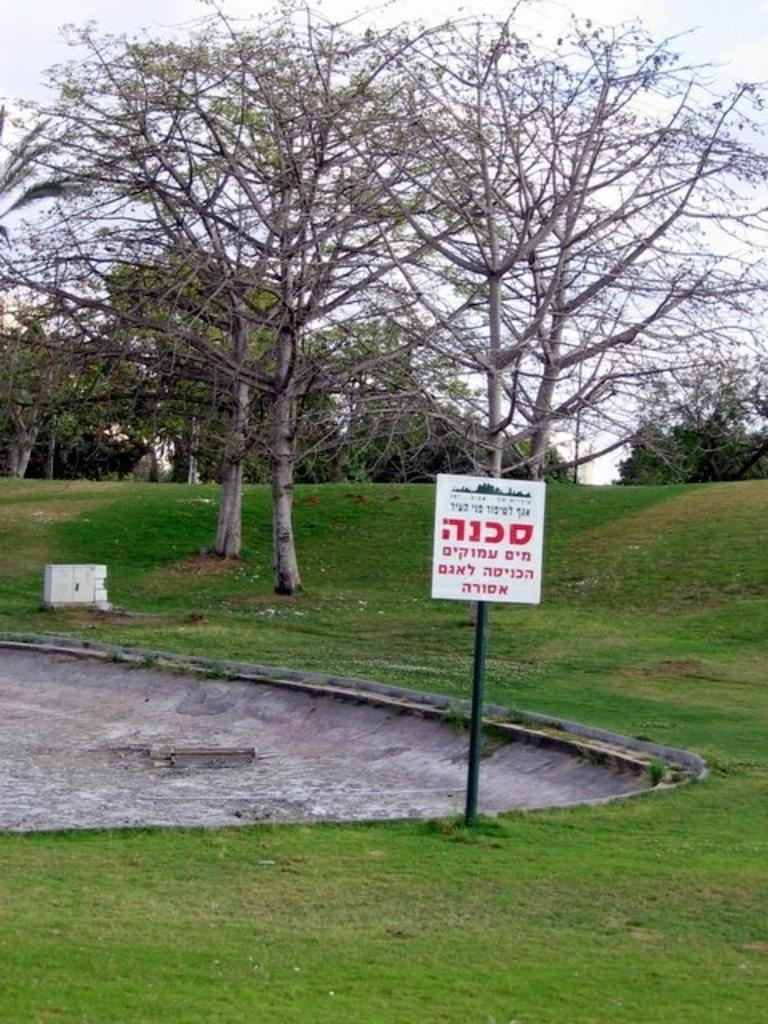What is attached to the pole in the image? There is a board attached to the pole in the image. What type of structure is present near the pole? There is a small wall in the image. What type of vegetation can be seen in the image? There are trees in the image. What is visible in the sky in the image? There are clouds visible in the image. What type of education does the son receive in the image? There is no son or education present in the image. What is the limit of the clouds visible in the image? The clouds do not have a limit in the image; they are simply visible in the sky. 